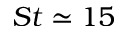Convert formula to latex. <formula><loc_0><loc_0><loc_500><loc_500>S t \simeq 1 5</formula> 